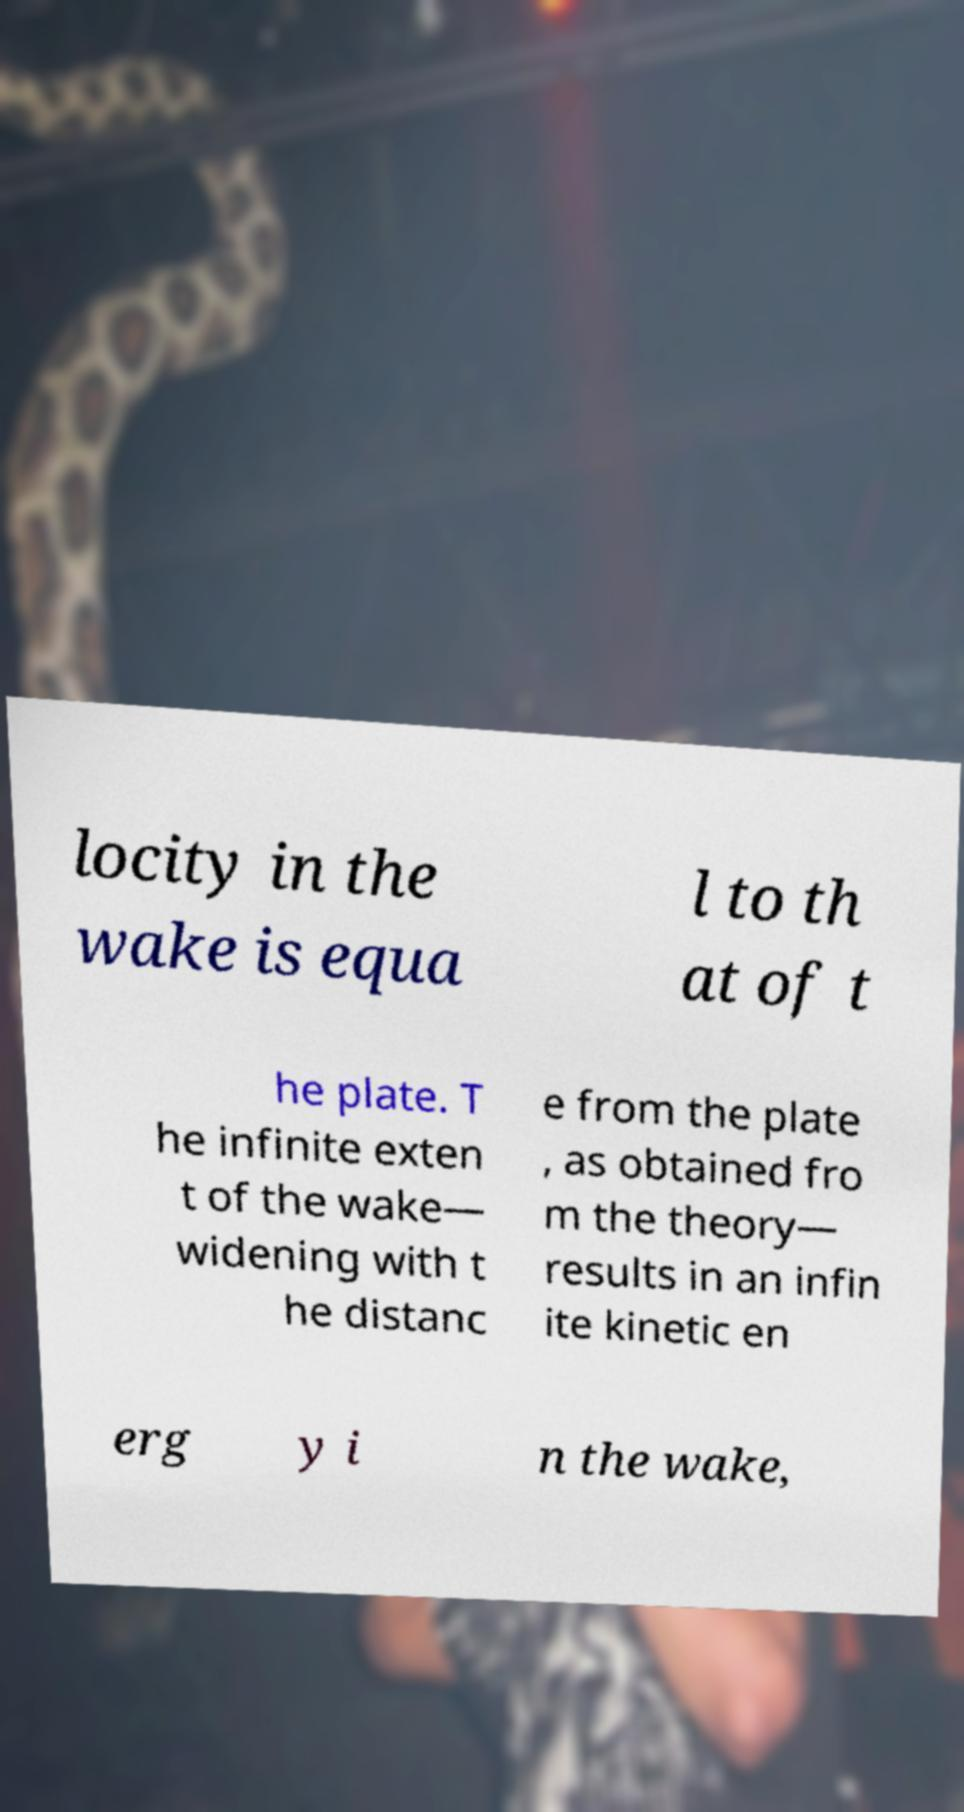There's text embedded in this image that I need extracted. Can you transcribe it verbatim? locity in the wake is equa l to th at of t he plate. T he infinite exten t of the wake— widening with t he distanc e from the plate , as obtained fro m the theory— results in an infin ite kinetic en erg y i n the wake, 